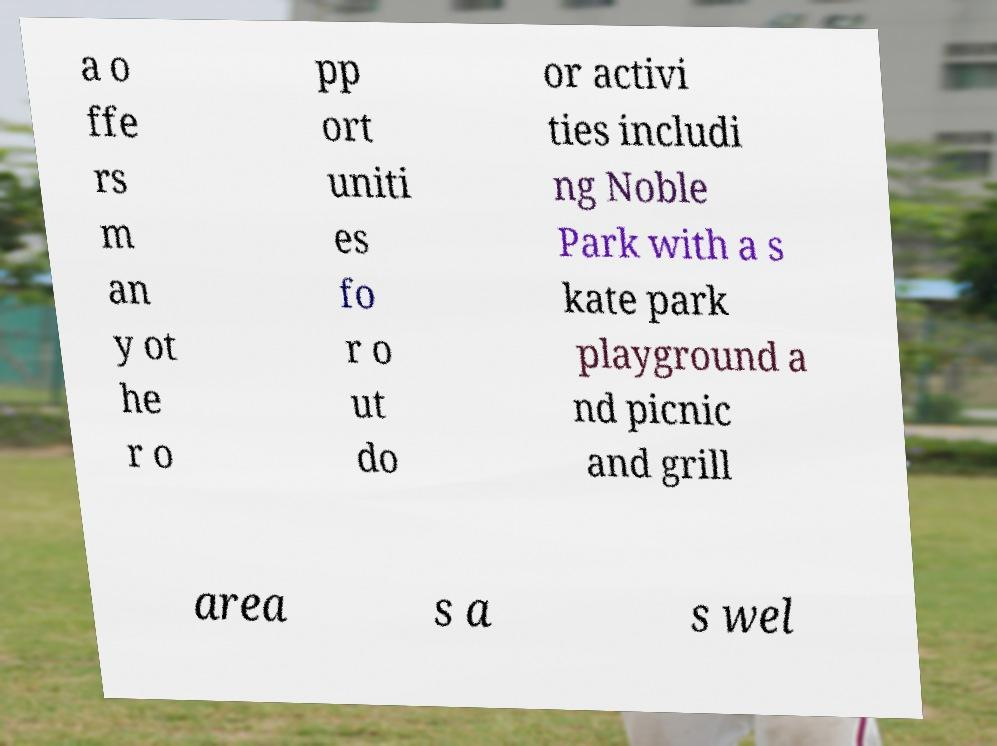There's text embedded in this image that I need extracted. Can you transcribe it verbatim? a o ffe rs m an y ot he r o pp ort uniti es fo r o ut do or activi ties includi ng Noble Park with a s kate park playground a nd picnic and grill area s a s wel 